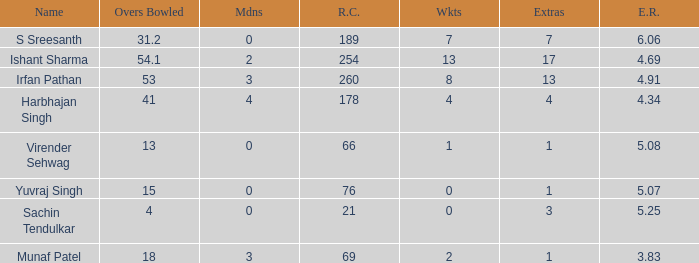Could you parse the entire table as a dict? {'header': ['Name', 'Overs Bowled', 'Mdns', 'R.C.', 'Wkts', 'Extras', 'E.R.'], 'rows': [['S Sreesanth', '31.2', '0', '189', '7', '7', '6.06'], ['Ishant Sharma', '54.1', '2', '254', '13', '17', '4.69'], ['Irfan Pathan', '53', '3', '260', '8', '13', '4.91'], ['Harbhajan Singh', '41', '4', '178', '4', '4', '4.34'], ['Virender Sehwag', '13', '0', '66', '1', '1', '5.08'], ['Yuvraj Singh', '15', '0', '76', '0', '1', '5.07'], ['Sachin Tendulkar', '4', '0', '21', '0', '3', '5.25'], ['Munaf Patel', '18', '3', '69', '2', '1', '3.83']]} Name the total number of wickets being yuvraj singh 1.0. 